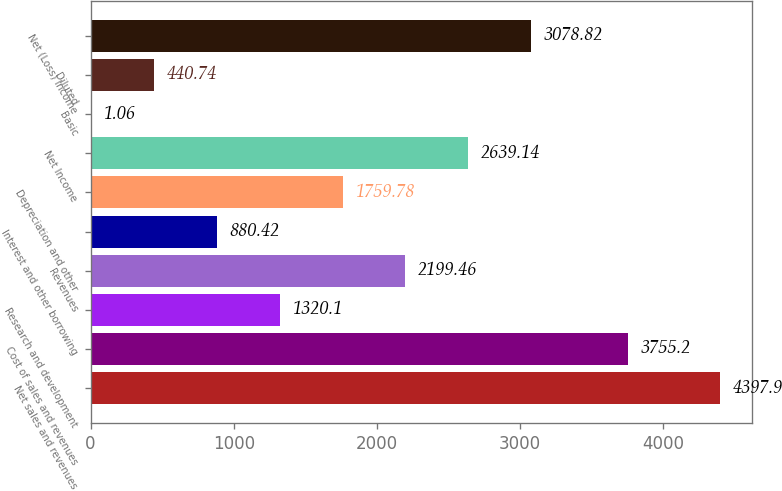Convert chart. <chart><loc_0><loc_0><loc_500><loc_500><bar_chart><fcel>Net sales and revenues<fcel>Cost of sales and revenues<fcel>Research and development<fcel>Revenues<fcel>Interest and other borrowing<fcel>Depreciation and other<fcel>Net Income<fcel>Basic<fcel>Diluted<fcel>Net (Loss) Income<nl><fcel>4397.9<fcel>3755.2<fcel>1320.1<fcel>2199.46<fcel>880.42<fcel>1759.78<fcel>2639.14<fcel>1.06<fcel>440.74<fcel>3078.82<nl></chart> 